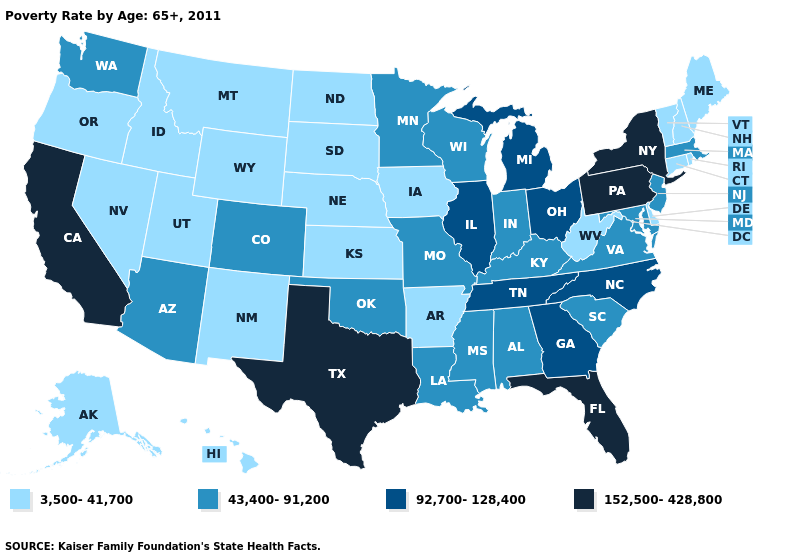Does West Virginia have the lowest value in the South?
Be succinct. Yes. What is the value of Arizona?
Concise answer only. 43,400-91,200. What is the value of Wyoming?
Keep it brief. 3,500-41,700. Which states have the lowest value in the USA?
Give a very brief answer. Alaska, Arkansas, Connecticut, Delaware, Hawaii, Idaho, Iowa, Kansas, Maine, Montana, Nebraska, Nevada, New Hampshire, New Mexico, North Dakota, Oregon, Rhode Island, South Dakota, Utah, Vermont, West Virginia, Wyoming. What is the lowest value in states that border Florida?
Answer briefly. 43,400-91,200. Name the states that have a value in the range 43,400-91,200?
Keep it brief. Alabama, Arizona, Colorado, Indiana, Kentucky, Louisiana, Maryland, Massachusetts, Minnesota, Mississippi, Missouri, New Jersey, Oklahoma, South Carolina, Virginia, Washington, Wisconsin. Which states have the highest value in the USA?
Give a very brief answer. California, Florida, New York, Pennsylvania, Texas. What is the value of Oregon?
Give a very brief answer. 3,500-41,700. What is the value of Illinois?
Be succinct. 92,700-128,400. Which states hav the highest value in the West?
Keep it brief. California. What is the value of Wisconsin?
Short answer required. 43,400-91,200. What is the value of New York?
Quick response, please. 152,500-428,800. Does Tennessee have the lowest value in the South?
Keep it brief. No. Name the states that have a value in the range 92,700-128,400?
Concise answer only. Georgia, Illinois, Michigan, North Carolina, Ohio, Tennessee. Does Idaho have a higher value than Nevada?
Short answer required. No. 